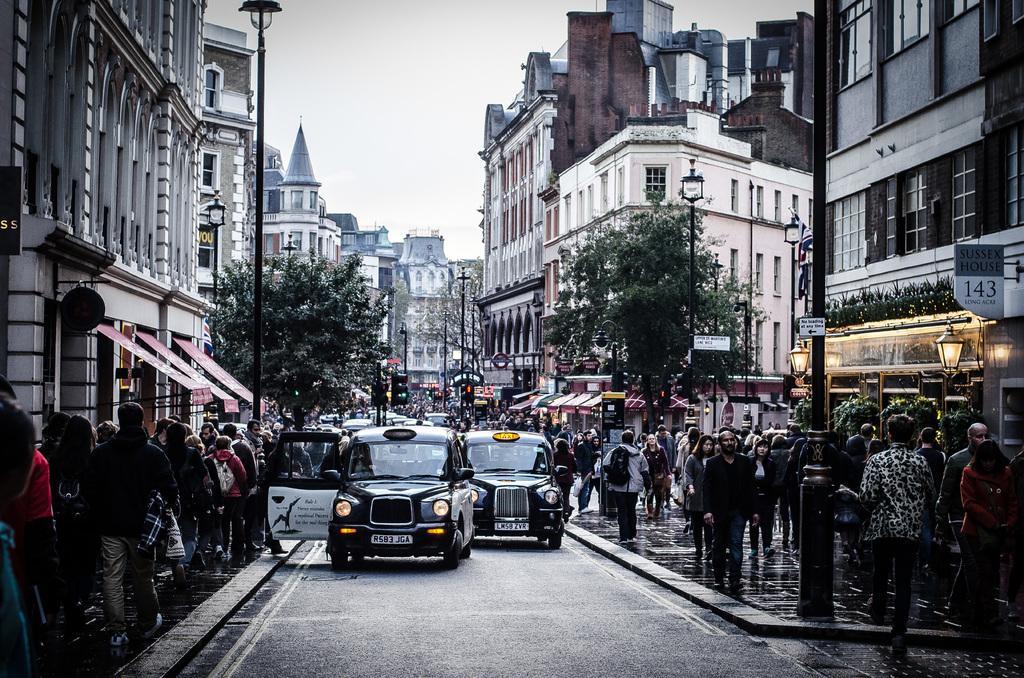Could you give a brief overview of what you see in this image? In this image we can see group of vehicles parked on the road. In the foreground we can see a group of people standing on the ground, light poles. In the background, we can see some buildings with windows, sign boards with text and the sky. 